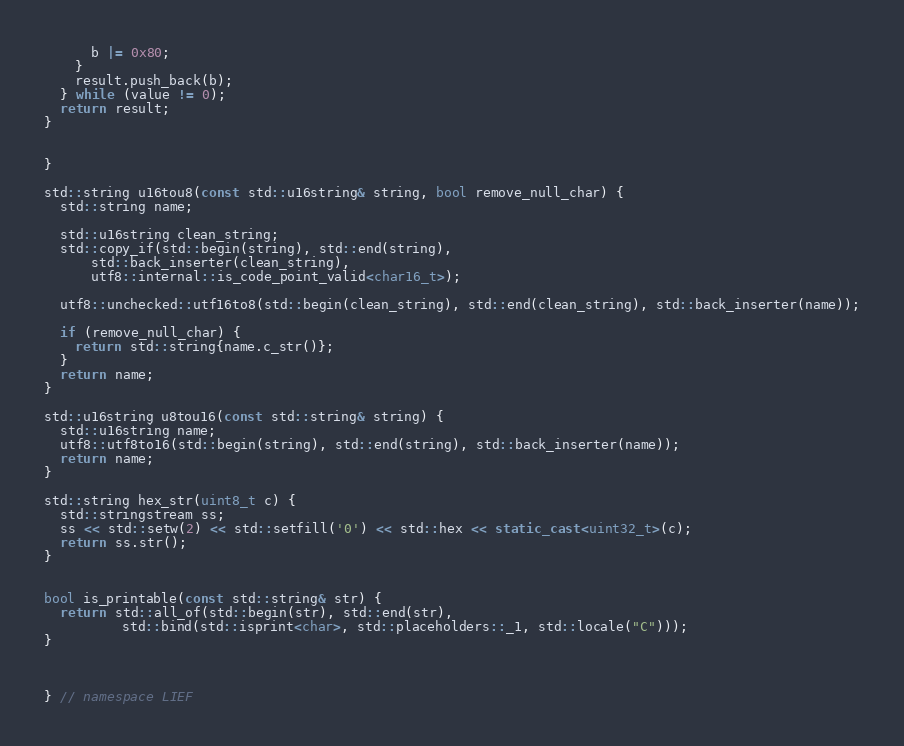<code> <loc_0><loc_0><loc_500><loc_500><_C++_>      b |= 0x80;
    }
    result.push_back(b);
  } while (value != 0);
  return result;
}


}

std::string u16tou8(const std::u16string& string, bool remove_null_char) {
  std::string name;

  std::u16string clean_string;
  std::copy_if(std::begin(string), std::end(string),
      std::back_inserter(clean_string),
      utf8::internal::is_code_point_valid<char16_t>);

  utf8::unchecked::utf16to8(std::begin(clean_string), std::end(clean_string), std::back_inserter(name));

  if (remove_null_char) {
    return std::string{name.c_str()};
  }
  return name;
}

std::u16string u8tou16(const std::string& string) {
  std::u16string name;
  utf8::utf8to16(std::begin(string), std::end(string), std::back_inserter(name));
  return name;
}

std::string hex_str(uint8_t c) {
  std::stringstream ss;
  ss << std::setw(2) << std::setfill('0') << std::hex << static_cast<uint32_t>(c);
  return ss.str();
}


bool is_printable(const std::string& str) {
  return std::all_of(std::begin(str), std::end(str),
          std::bind(std::isprint<char>, std::placeholders::_1, std::locale("C")));
}



} // namespace LIEF
</code> 